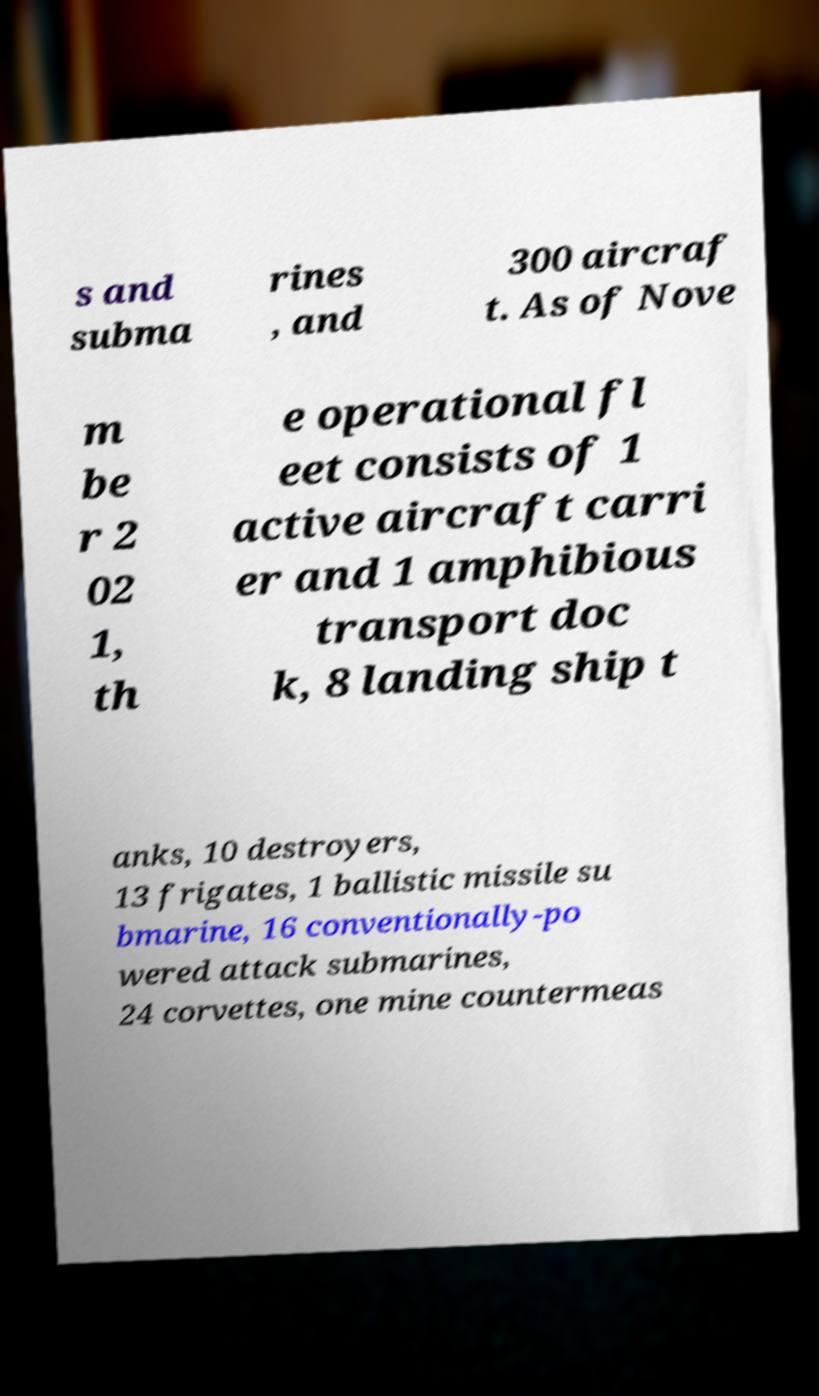Please identify and transcribe the text found in this image. s and subma rines , and 300 aircraf t. As of Nove m be r 2 02 1, th e operational fl eet consists of 1 active aircraft carri er and 1 amphibious transport doc k, 8 landing ship t anks, 10 destroyers, 13 frigates, 1 ballistic missile su bmarine, 16 conventionally-po wered attack submarines, 24 corvettes, one mine countermeas 